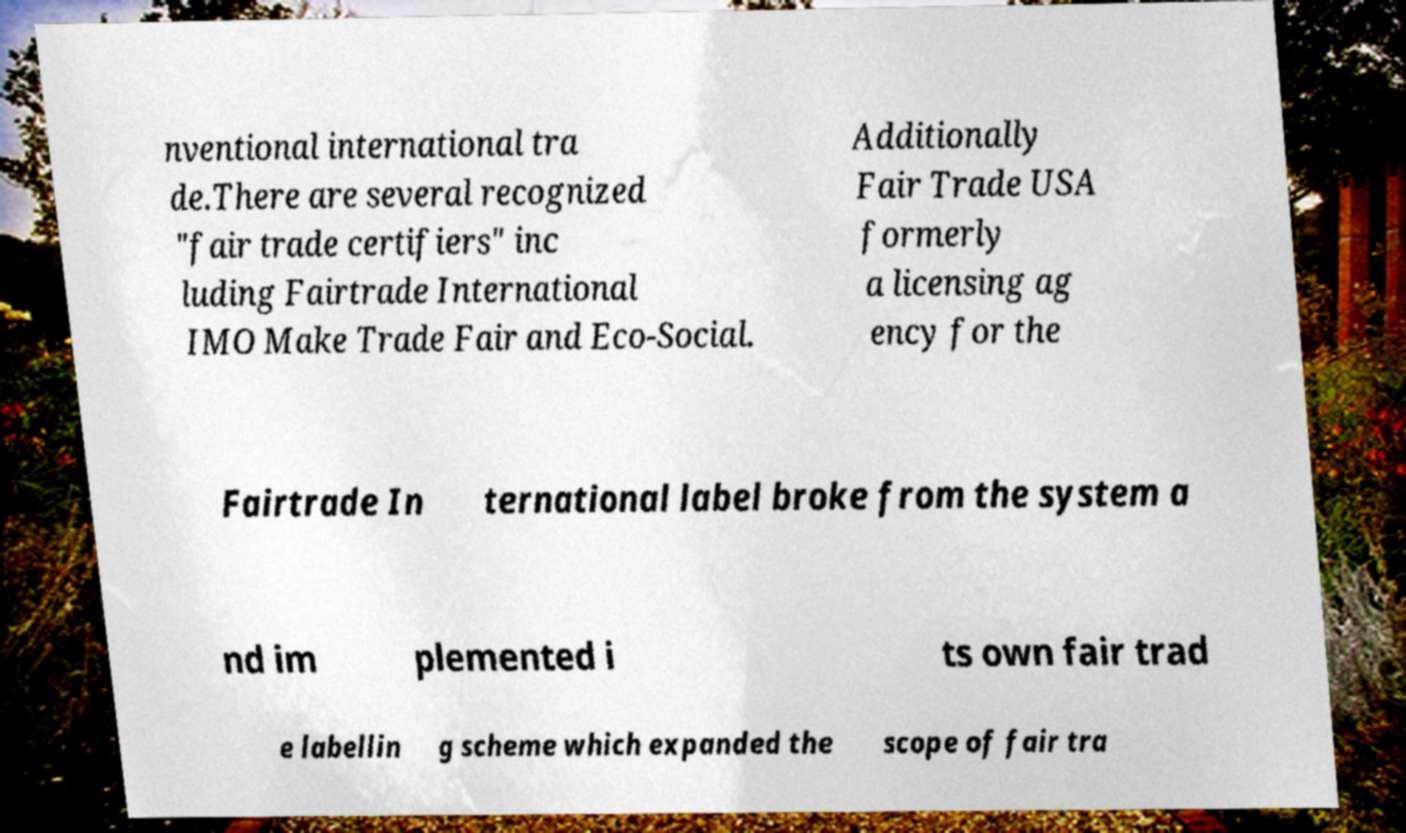Could you assist in decoding the text presented in this image and type it out clearly? nventional international tra de.There are several recognized "fair trade certifiers" inc luding Fairtrade International IMO Make Trade Fair and Eco-Social. Additionally Fair Trade USA formerly a licensing ag ency for the Fairtrade In ternational label broke from the system a nd im plemented i ts own fair trad e labellin g scheme which expanded the scope of fair tra 